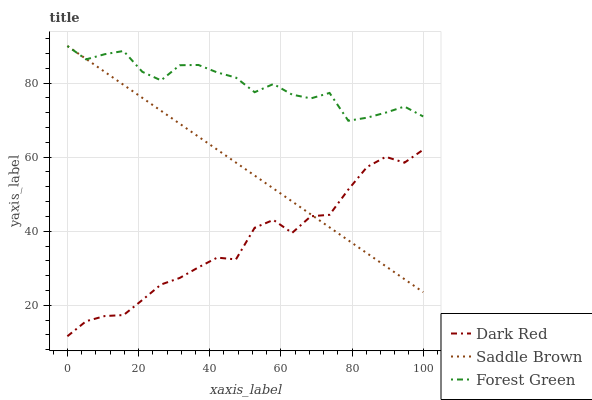Does Dark Red have the minimum area under the curve?
Answer yes or no. Yes. Does Forest Green have the maximum area under the curve?
Answer yes or no. Yes. Does Saddle Brown have the minimum area under the curve?
Answer yes or no. No. Does Saddle Brown have the maximum area under the curve?
Answer yes or no. No. Is Saddle Brown the smoothest?
Answer yes or no. Yes. Is Forest Green the roughest?
Answer yes or no. Yes. Is Forest Green the smoothest?
Answer yes or no. No. Is Saddle Brown the roughest?
Answer yes or no. No. Does Dark Red have the lowest value?
Answer yes or no. Yes. Does Saddle Brown have the lowest value?
Answer yes or no. No. Does Saddle Brown have the highest value?
Answer yes or no. Yes. Is Dark Red less than Forest Green?
Answer yes or no. Yes. Is Forest Green greater than Dark Red?
Answer yes or no. Yes. Does Dark Red intersect Saddle Brown?
Answer yes or no. Yes. Is Dark Red less than Saddle Brown?
Answer yes or no. No. Is Dark Red greater than Saddle Brown?
Answer yes or no. No. Does Dark Red intersect Forest Green?
Answer yes or no. No. 